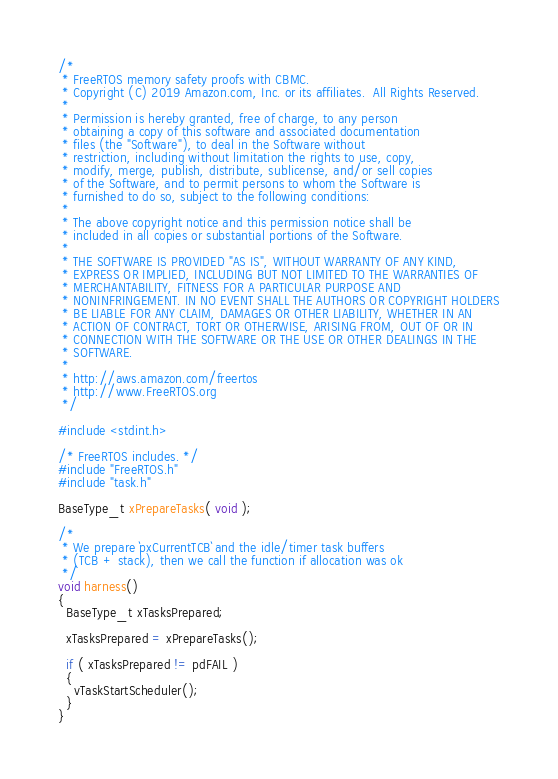Convert code to text. <code><loc_0><loc_0><loc_500><loc_500><_C_>/*
 * FreeRTOS memory safety proofs with CBMC.
 * Copyright (C) 2019 Amazon.com, Inc. or its affiliates.  All Rights Reserved.
 *
 * Permission is hereby granted, free of charge, to any person
 * obtaining a copy of this software and associated documentation
 * files (the "Software"), to deal in the Software without
 * restriction, including without limitation the rights to use, copy,
 * modify, merge, publish, distribute, sublicense, and/or sell copies
 * of the Software, and to permit persons to whom the Software is
 * furnished to do so, subject to the following conditions:
 *
 * The above copyright notice and this permission notice shall be
 * included in all copies or substantial portions of the Software.
 *
 * THE SOFTWARE IS PROVIDED "AS IS", WITHOUT WARRANTY OF ANY KIND,
 * EXPRESS OR IMPLIED, INCLUDING BUT NOT LIMITED TO THE WARRANTIES OF
 * MERCHANTABILITY, FITNESS FOR A PARTICULAR PURPOSE AND
 * NONINFRINGEMENT. IN NO EVENT SHALL THE AUTHORS OR COPYRIGHT HOLDERS
 * BE LIABLE FOR ANY CLAIM, DAMAGES OR OTHER LIABILITY, WHETHER IN AN
 * ACTION OF CONTRACT, TORT OR OTHERWISE, ARISING FROM, OUT OF OR IN
 * CONNECTION WITH THE SOFTWARE OR THE USE OR OTHER DEALINGS IN THE
 * SOFTWARE.
 *
 * http://aws.amazon.com/freertos
 * http://www.FreeRTOS.org
 */

#include <stdint.h>

/* FreeRTOS includes. */
#include "FreeRTOS.h"
#include "task.h"

BaseType_t xPrepareTasks( void );

/*
 * We prepare `pxCurrentTCB` and the idle/timer task buffers
 * (TCB + stack), then we call the function if allocation was ok
 */
void harness()
{
  BaseType_t xTasksPrepared;

  xTasksPrepared = xPrepareTasks();

  if ( xTasksPrepared != pdFAIL )
  {
    vTaskStartScheduler();
  }
}
</code> 